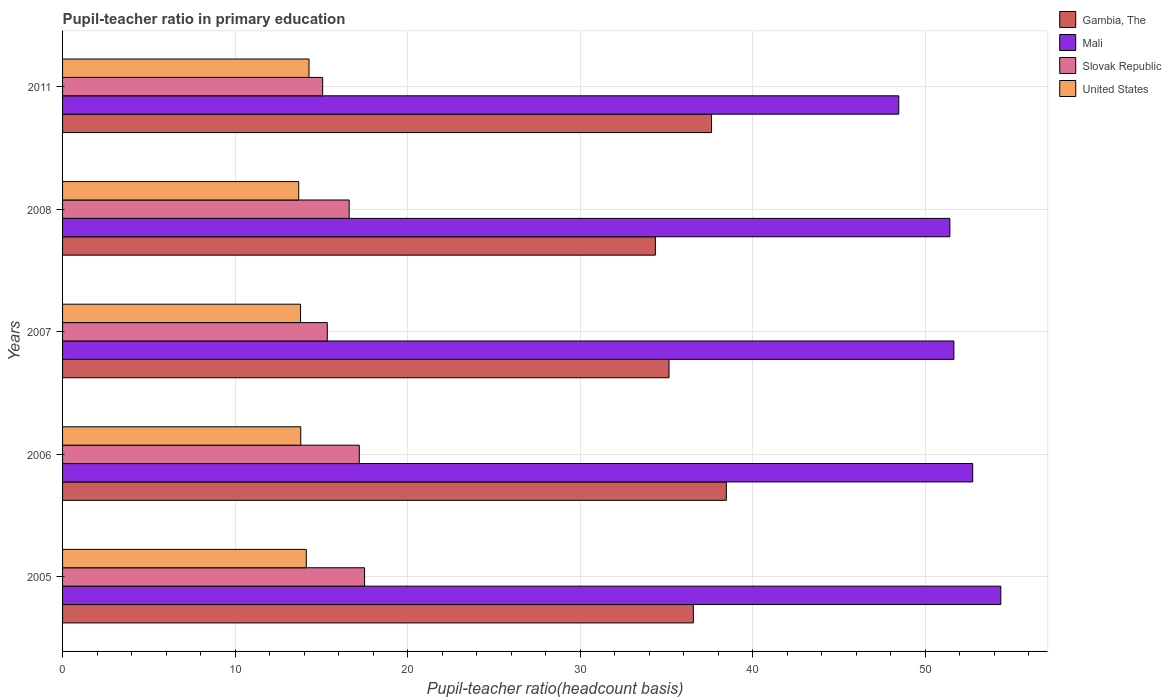Are the number of bars per tick equal to the number of legend labels?
Make the answer very short. Yes. In how many cases, is the number of bars for a given year not equal to the number of legend labels?
Keep it short and to the point. 0. What is the pupil-teacher ratio in primary education in Mali in 2006?
Keep it short and to the point. 52.76. Across all years, what is the maximum pupil-teacher ratio in primary education in Mali?
Your answer should be very brief. 54.39. Across all years, what is the minimum pupil-teacher ratio in primary education in United States?
Provide a succinct answer. 13.69. In which year was the pupil-teacher ratio in primary education in United States maximum?
Your answer should be compact. 2011. In which year was the pupil-teacher ratio in primary education in Slovak Republic minimum?
Give a very brief answer. 2011. What is the total pupil-teacher ratio in primary education in Slovak Republic in the graph?
Give a very brief answer. 81.75. What is the difference between the pupil-teacher ratio in primary education in Mali in 2005 and that in 2007?
Offer a very short reply. 2.72. What is the difference between the pupil-teacher ratio in primary education in Mali in 2006 and the pupil-teacher ratio in primary education in United States in 2007?
Keep it short and to the point. 38.96. What is the average pupil-teacher ratio in primary education in Slovak Republic per year?
Provide a short and direct response. 16.35. In the year 2005, what is the difference between the pupil-teacher ratio in primary education in Slovak Republic and pupil-teacher ratio in primary education in United States?
Give a very brief answer. 3.38. What is the ratio of the pupil-teacher ratio in primary education in Mali in 2007 to that in 2008?
Ensure brevity in your answer.  1. Is the pupil-teacher ratio in primary education in Slovak Republic in 2005 less than that in 2008?
Keep it short and to the point. No. Is the difference between the pupil-teacher ratio in primary education in Slovak Republic in 2006 and 2008 greater than the difference between the pupil-teacher ratio in primary education in United States in 2006 and 2008?
Make the answer very short. Yes. What is the difference between the highest and the second highest pupil-teacher ratio in primary education in Mali?
Your answer should be very brief. 1.63. What is the difference between the highest and the lowest pupil-teacher ratio in primary education in Slovak Republic?
Make the answer very short. 2.43. In how many years, is the pupil-teacher ratio in primary education in Slovak Republic greater than the average pupil-teacher ratio in primary education in Slovak Republic taken over all years?
Ensure brevity in your answer.  3. Is the sum of the pupil-teacher ratio in primary education in Gambia, The in 2005 and 2011 greater than the maximum pupil-teacher ratio in primary education in Mali across all years?
Your answer should be compact. Yes. What does the 2nd bar from the top in 2007 represents?
Your answer should be very brief. Slovak Republic. What does the 2nd bar from the bottom in 2007 represents?
Give a very brief answer. Mali. How many bars are there?
Your answer should be compact. 20. Does the graph contain grids?
Offer a terse response. Yes. How many legend labels are there?
Give a very brief answer. 4. How are the legend labels stacked?
Your answer should be very brief. Vertical. What is the title of the graph?
Your response must be concise. Pupil-teacher ratio in primary education. Does "France" appear as one of the legend labels in the graph?
Your response must be concise. No. What is the label or title of the X-axis?
Your response must be concise. Pupil-teacher ratio(headcount basis). What is the label or title of the Y-axis?
Offer a very short reply. Years. What is the Pupil-teacher ratio(headcount basis) of Gambia, The in 2005?
Provide a succinct answer. 36.56. What is the Pupil-teacher ratio(headcount basis) of Mali in 2005?
Make the answer very short. 54.39. What is the Pupil-teacher ratio(headcount basis) in Slovak Republic in 2005?
Make the answer very short. 17.51. What is the Pupil-teacher ratio(headcount basis) in United States in 2005?
Your answer should be very brief. 14.13. What is the Pupil-teacher ratio(headcount basis) of Gambia, The in 2006?
Provide a succinct answer. 38.48. What is the Pupil-teacher ratio(headcount basis) of Mali in 2006?
Your response must be concise. 52.76. What is the Pupil-teacher ratio(headcount basis) in Slovak Republic in 2006?
Your answer should be compact. 17.2. What is the Pupil-teacher ratio(headcount basis) of United States in 2006?
Your response must be concise. 13.81. What is the Pupil-teacher ratio(headcount basis) of Gambia, The in 2007?
Your response must be concise. 35.16. What is the Pupil-teacher ratio(headcount basis) in Mali in 2007?
Your answer should be very brief. 51.67. What is the Pupil-teacher ratio(headcount basis) of Slovak Republic in 2007?
Make the answer very short. 15.35. What is the Pupil-teacher ratio(headcount basis) of United States in 2007?
Give a very brief answer. 13.8. What is the Pupil-teacher ratio(headcount basis) of Gambia, The in 2008?
Ensure brevity in your answer.  34.36. What is the Pupil-teacher ratio(headcount basis) in Mali in 2008?
Provide a succinct answer. 51.44. What is the Pupil-teacher ratio(headcount basis) in Slovak Republic in 2008?
Provide a succinct answer. 16.61. What is the Pupil-teacher ratio(headcount basis) in United States in 2008?
Make the answer very short. 13.69. What is the Pupil-teacher ratio(headcount basis) of Gambia, The in 2011?
Your answer should be compact. 37.62. What is the Pupil-teacher ratio(headcount basis) of Mali in 2011?
Provide a short and direct response. 48.47. What is the Pupil-teacher ratio(headcount basis) in Slovak Republic in 2011?
Your answer should be compact. 15.08. What is the Pupil-teacher ratio(headcount basis) in United States in 2011?
Offer a terse response. 14.29. Across all years, what is the maximum Pupil-teacher ratio(headcount basis) in Gambia, The?
Provide a short and direct response. 38.48. Across all years, what is the maximum Pupil-teacher ratio(headcount basis) of Mali?
Your answer should be very brief. 54.39. Across all years, what is the maximum Pupil-teacher ratio(headcount basis) in Slovak Republic?
Your answer should be very brief. 17.51. Across all years, what is the maximum Pupil-teacher ratio(headcount basis) in United States?
Provide a short and direct response. 14.29. Across all years, what is the minimum Pupil-teacher ratio(headcount basis) in Gambia, The?
Make the answer very short. 34.36. Across all years, what is the minimum Pupil-teacher ratio(headcount basis) in Mali?
Provide a short and direct response. 48.47. Across all years, what is the minimum Pupil-teacher ratio(headcount basis) in Slovak Republic?
Make the answer very short. 15.08. Across all years, what is the minimum Pupil-teacher ratio(headcount basis) of United States?
Your answer should be very brief. 13.69. What is the total Pupil-teacher ratio(headcount basis) in Gambia, The in the graph?
Your response must be concise. 182.18. What is the total Pupil-teacher ratio(headcount basis) in Mali in the graph?
Make the answer very short. 258.73. What is the total Pupil-teacher ratio(headcount basis) of Slovak Republic in the graph?
Offer a terse response. 81.75. What is the total Pupil-teacher ratio(headcount basis) in United States in the graph?
Provide a short and direct response. 69.71. What is the difference between the Pupil-teacher ratio(headcount basis) of Gambia, The in 2005 and that in 2006?
Your response must be concise. -1.91. What is the difference between the Pupil-teacher ratio(headcount basis) in Mali in 2005 and that in 2006?
Your answer should be very brief. 1.63. What is the difference between the Pupil-teacher ratio(headcount basis) in Slovak Republic in 2005 and that in 2006?
Keep it short and to the point. 0.31. What is the difference between the Pupil-teacher ratio(headcount basis) of United States in 2005 and that in 2006?
Make the answer very short. 0.32. What is the difference between the Pupil-teacher ratio(headcount basis) in Gambia, The in 2005 and that in 2007?
Offer a very short reply. 1.41. What is the difference between the Pupil-teacher ratio(headcount basis) of Mali in 2005 and that in 2007?
Offer a terse response. 2.72. What is the difference between the Pupil-teacher ratio(headcount basis) of Slovak Republic in 2005 and that in 2007?
Your answer should be compact. 2.16. What is the difference between the Pupil-teacher ratio(headcount basis) in United States in 2005 and that in 2007?
Your answer should be very brief. 0.33. What is the difference between the Pupil-teacher ratio(headcount basis) of Gambia, The in 2005 and that in 2008?
Make the answer very short. 2.2. What is the difference between the Pupil-teacher ratio(headcount basis) of Mali in 2005 and that in 2008?
Your response must be concise. 2.95. What is the difference between the Pupil-teacher ratio(headcount basis) of Slovak Republic in 2005 and that in 2008?
Provide a succinct answer. 0.89. What is the difference between the Pupil-teacher ratio(headcount basis) of United States in 2005 and that in 2008?
Provide a short and direct response. 0.44. What is the difference between the Pupil-teacher ratio(headcount basis) of Gambia, The in 2005 and that in 2011?
Your answer should be very brief. -1.05. What is the difference between the Pupil-teacher ratio(headcount basis) of Mali in 2005 and that in 2011?
Ensure brevity in your answer.  5.91. What is the difference between the Pupil-teacher ratio(headcount basis) in Slovak Republic in 2005 and that in 2011?
Give a very brief answer. 2.43. What is the difference between the Pupil-teacher ratio(headcount basis) of United States in 2005 and that in 2011?
Your response must be concise. -0.16. What is the difference between the Pupil-teacher ratio(headcount basis) of Gambia, The in 2006 and that in 2007?
Offer a terse response. 3.32. What is the difference between the Pupil-teacher ratio(headcount basis) in Mali in 2006 and that in 2007?
Make the answer very short. 1.09. What is the difference between the Pupil-teacher ratio(headcount basis) of Slovak Republic in 2006 and that in 2007?
Ensure brevity in your answer.  1.85. What is the difference between the Pupil-teacher ratio(headcount basis) in United States in 2006 and that in 2007?
Provide a succinct answer. 0.01. What is the difference between the Pupil-teacher ratio(headcount basis) in Gambia, The in 2006 and that in 2008?
Make the answer very short. 4.11. What is the difference between the Pupil-teacher ratio(headcount basis) of Mali in 2006 and that in 2008?
Give a very brief answer. 1.32. What is the difference between the Pupil-teacher ratio(headcount basis) in Slovak Republic in 2006 and that in 2008?
Give a very brief answer. 0.59. What is the difference between the Pupil-teacher ratio(headcount basis) in United States in 2006 and that in 2008?
Provide a succinct answer. 0.12. What is the difference between the Pupil-teacher ratio(headcount basis) of Gambia, The in 2006 and that in 2011?
Your answer should be compact. 0.86. What is the difference between the Pupil-teacher ratio(headcount basis) in Mali in 2006 and that in 2011?
Provide a short and direct response. 4.29. What is the difference between the Pupil-teacher ratio(headcount basis) of Slovak Republic in 2006 and that in 2011?
Provide a succinct answer. 2.12. What is the difference between the Pupil-teacher ratio(headcount basis) of United States in 2006 and that in 2011?
Your answer should be very brief. -0.48. What is the difference between the Pupil-teacher ratio(headcount basis) of Gambia, The in 2007 and that in 2008?
Make the answer very short. 0.79. What is the difference between the Pupil-teacher ratio(headcount basis) in Mali in 2007 and that in 2008?
Your answer should be compact. 0.23. What is the difference between the Pupil-teacher ratio(headcount basis) in Slovak Republic in 2007 and that in 2008?
Provide a short and direct response. -1.27. What is the difference between the Pupil-teacher ratio(headcount basis) of United States in 2007 and that in 2008?
Give a very brief answer. 0.11. What is the difference between the Pupil-teacher ratio(headcount basis) of Gambia, The in 2007 and that in 2011?
Provide a succinct answer. -2.46. What is the difference between the Pupil-teacher ratio(headcount basis) of Mali in 2007 and that in 2011?
Provide a succinct answer. 3.2. What is the difference between the Pupil-teacher ratio(headcount basis) of Slovak Republic in 2007 and that in 2011?
Offer a very short reply. 0.27. What is the difference between the Pupil-teacher ratio(headcount basis) in United States in 2007 and that in 2011?
Offer a very short reply. -0.49. What is the difference between the Pupil-teacher ratio(headcount basis) in Gambia, The in 2008 and that in 2011?
Keep it short and to the point. -3.25. What is the difference between the Pupil-teacher ratio(headcount basis) of Mali in 2008 and that in 2011?
Your response must be concise. 2.96. What is the difference between the Pupil-teacher ratio(headcount basis) in Slovak Republic in 2008 and that in 2011?
Offer a terse response. 1.54. What is the difference between the Pupil-teacher ratio(headcount basis) of United States in 2008 and that in 2011?
Your answer should be very brief. -0.6. What is the difference between the Pupil-teacher ratio(headcount basis) in Gambia, The in 2005 and the Pupil-teacher ratio(headcount basis) in Mali in 2006?
Ensure brevity in your answer.  -16.2. What is the difference between the Pupil-teacher ratio(headcount basis) in Gambia, The in 2005 and the Pupil-teacher ratio(headcount basis) in Slovak Republic in 2006?
Offer a very short reply. 19.36. What is the difference between the Pupil-teacher ratio(headcount basis) in Gambia, The in 2005 and the Pupil-teacher ratio(headcount basis) in United States in 2006?
Give a very brief answer. 22.76. What is the difference between the Pupil-teacher ratio(headcount basis) of Mali in 2005 and the Pupil-teacher ratio(headcount basis) of Slovak Republic in 2006?
Keep it short and to the point. 37.19. What is the difference between the Pupil-teacher ratio(headcount basis) in Mali in 2005 and the Pupil-teacher ratio(headcount basis) in United States in 2006?
Keep it short and to the point. 40.58. What is the difference between the Pupil-teacher ratio(headcount basis) in Slovak Republic in 2005 and the Pupil-teacher ratio(headcount basis) in United States in 2006?
Keep it short and to the point. 3.7. What is the difference between the Pupil-teacher ratio(headcount basis) of Gambia, The in 2005 and the Pupil-teacher ratio(headcount basis) of Mali in 2007?
Make the answer very short. -15.1. What is the difference between the Pupil-teacher ratio(headcount basis) in Gambia, The in 2005 and the Pupil-teacher ratio(headcount basis) in Slovak Republic in 2007?
Your answer should be compact. 21.22. What is the difference between the Pupil-teacher ratio(headcount basis) in Gambia, The in 2005 and the Pupil-teacher ratio(headcount basis) in United States in 2007?
Make the answer very short. 22.77. What is the difference between the Pupil-teacher ratio(headcount basis) of Mali in 2005 and the Pupil-teacher ratio(headcount basis) of Slovak Republic in 2007?
Ensure brevity in your answer.  39.04. What is the difference between the Pupil-teacher ratio(headcount basis) of Mali in 2005 and the Pupil-teacher ratio(headcount basis) of United States in 2007?
Your answer should be very brief. 40.59. What is the difference between the Pupil-teacher ratio(headcount basis) in Slovak Republic in 2005 and the Pupil-teacher ratio(headcount basis) in United States in 2007?
Your answer should be compact. 3.71. What is the difference between the Pupil-teacher ratio(headcount basis) in Gambia, The in 2005 and the Pupil-teacher ratio(headcount basis) in Mali in 2008?
Provide a succinct answer. -14.87. What is the difference between the Pupil-teacher ratio(headcount basis) of Gambia, The in 2005 and the Pupil-teacher ratio(headcount basis) of Slovak Republic in 2008?
Your answer should be very brief. 19.95. What is the difference between the Pupil-teacher ratio(headcount basis) in Gambia, The in 2005 and the Pupil-teacher ratio(headcount basis) in United States in 2008?
Provide a succinct answer. 22.88. What is the difference between the Pupil-teacher ratio(headcount basis) in Mali in 2005 and the Pupil-teacher ratio(headcount basis) in Slovak Republic in 2008?
Keep it short and to the point. 37.77. What is the difference between the Pupil-teacher ratio(headcount basis) in Mali in 2005 and the Pupil-teacher ratio(headcount basis) in United States in 2008?
Your answer should be very brief. 40.7. What is the difference between the Pupil-teacher ratio(headcount basis) in Slovak Republic in 2005 and the Pupil-teacher ratio(headcount basis) in United States in 2008?
Give a very brief answer. 3.82. What is the difference between the Pupil-teacher ratio(headcount basis) in Gambia, The in 2005 and the Pupil-teacher ratio(headcount basis) in Mali in 2011?
Make the answer very short. -11.91. What is the difference between the Pupil-teacher ratio(headcount basis) of Gambia, The in 2005 and the Pupil-teacher ratio(headcount basis) of Slovak Republic in 2011?
Make the answer very short. 21.49. What is the difference between the Pupil-teacher ratio(headcount basis) in Gambia, The in 2005 and the Pupil-teacher ratio(headcount basis) in United States in 2011?
Give a very brief answer. 22.28. What is the difference between the Pupil-teacher ratio(headcount basis) in Mali in 2005 and the Pupil-teacher ratio(headcount basis) in Slovak Republic in 2011?
Offer a terse response. 39.31. What is the difference between the Pupil-teacher ratio(headcount basis) in Mali in 2005 and the Pupil-teacher ratio(headcount basis) in United States in 2011?
Offer a terse response. 40.1. What is the difference between the Pupil-teacher ratio(headcount basis) of Slovak Republic in 2005 and the Pupil-teacher ratio(headcount basis) of United States in 2011?
Offer a terse response. 3.22. What is the difference between the Pupil-teacher ratio(headcount basis) of Gambia, The in 2006 and the Pupil-teacher ratio(headcount basis) of Mali in 2007?
Your answer should be very brief. -13.19. What is the difference between the Pupil-teacher ratio(headcount basis) in Gambia, The in 2006 and the Pupil-teacher ratio(headcount basis) in Slovak Republic in 2007?
Provide a succinct answer. 23.13. What is the difference between the Pupil-teacher ratio(headcount basis) in Gambia, The in 2006 and the Pupil-teacher ratio(headcount basis) in United States in 2007?
Give a very brief answer. 24.68. What is the difference between the Pupil-teacher ratio(headcount basis) in Mali in 2006 and the Pupil-teacher ratio(headcount basis) in Slovak Republic in 2007?
Ensure brevity in your answer.  37.41. What is the difference between the Pupil-teacher ratio(headcount basis) in Mali in 2006 and the Pupil-teacher ratio(headcount basis) in United States in 2007?
Give a very brief answer. 38.96. What is the difference between the Pupil-teacher ratio(headcount basis) in Slovak Republic in 2006 and the Pupil-teacher ratio(headcount basis) in United States in 2007?
Ensure brevity in your answer.  3.41. What is the difference between the Pupil-teacher ratio(headcount basis) of Gambia, The in 2006 and the Pupil-teacher ratio(headcount basis) of Mali in 2008?
Keep it short and to the point. -12.96. What is the difference between the Pupil-teacher ratio(headcount basis) in Gambia, The in 2006 and the Pupil-teacher ratio(headcount basis) in Slovak Republic in 2008?
Provide a succinct answer. 21.86. What is the difference between the Pupil-teacher ratio(headcount basis) of Gambia, The in 2006 and the Pupil-teacher ratio(headcount basis) of United States in 2008?
Your answer should be very brief. 24.79. What is the difference between the Pupil-teacher ratio(headcount basis) in Mali in 2006 and the Pupil-teacher ratio(headcount basis) in Slovak Republic in 2008?
Offer a terse response. 36.15. What is the difference between the Pupil-teacher ratio(headcount basis) of Mali in 2006 and the Pupil-teacher ratio(headcount basis) of United States in 2008?
Offer a terse response. 39.07. What is the difference between the Pupil-teacher ratio(headcount basis) of Slovak Republic in 2006 and the Pupil-teacher ratio(headcount basis) of United States in 2008?
Offer a very short reply. 3.51. What is the difference between the Pupil-teacher ratio(headcount basis) in Gambia, The in 2006 and the Pupil-teacher ratio(headcount basis) in Mali in 2011?
Keep it short and to the point. -10. What is the difference between the Pupil-teacher ratio(headcount basis) of Gambia, The in 2006 and the Pupil-teacher ratio(headcount basis) of Slovak Republic in 2011?
Give a very brief answer. 23.4. What is the difference between the Pupil-teacher ratio(headcount basis) of Gambia, The in 2006 and the Pupil-teacher ratio(headcount basis) of United States in 2011?
Provide a short and direct response. 24.19. What is the difference between the Pupil-teacher ratio(headcount basis) of Mali in 2006 and the Pupil-teacher ratio(headcount basis) of Slovak Republic in 2011?
Your response must be concise. 37.68. What is the difference between the Pupil-teacher ratio(headcount basis) of Mali in 2006 and the Pupil-teacher ratio(headcount basis) of United States in 2011?
Your response must be concise. 38.48. What is the difference between the Pupil-teacher ratio(headcount basis) in Slovak Republic in 2006 and the Pupil-teacher ratio(headcount basis) in United States in 2011?
Provide a short and direct response. 2.92. What is the difference between the Pupil-teacher ratio(headcount basis) of Gambia, The in 2007 and the Pupil-teacher ratio(headcount basis) of Mali in 2008?
Your response must be concise. -16.28. What is the difference between the Pupil-teacher ratio(headcount basis) in Gambia, The in 2007 and the Pupil-teacher ratio(headcount basis) in Slovak Republic in 2008?
Provide a short and direct response. 18.54. What is the difference between the Pupil-teacher ratio(headcount basis) in Gambia, The in 2007 and the Pupil-teacher ratio(headcount basis) in United States in 2008?
Offer a terse response. 21.47. What is the difference between the Pupil-teacher ratio(headcount basis) of Mali in 2007 and the Pupil-teacher ratio(headcount basis) of Slovak Republic in 2008?
Provide a short and direct response. 35.05. What is the difference between the Pupil-teacher ratio(headcount basis) in Mali in 2007 and the Pupil-teacher ratio(headcount basis) in United States in 2008?
Give a very brief answer. 37.98. What is the difference between the Pupil-teacher ratio(headcount basis) of Slovak Republic in 2007 and the Pupil-teacher ratio(headcount basis) of United States in 2008?
Your response must be concise. 1.66. What is the difference between the Pupil-teacher ratio(headcount basis) of Gambia, The in 2007 and the Pupil-teacher ratio(headcount basis) of Mali in 2011?
Your answer should be very brief. -13.32. What is the difference between the Pupil-teacher ratio(headcount basis) in Gambia, The in 2007 and the Pupil-teacher ratio(headcount basis) in Slovak Republic in 2011?
Provide a succinct answer. 20.08. What is the difference between the Pupil-teacher ratio(headcount basis) of Gambia, The in 2007 and the Pupil-teacher ratio(headcount basis) of United States in 2011?
Keep it short and to the point. 20.87. What is the difference between the Pupil-teacher ratio(headcount basis) in Mali in 2007 and the Pupil-teacher ratio(headcount basis) in Slovak Republic in 2011?
Provide a short and direct response. 36.59. What is the difference between the Pupil-teacher ratio(headcount basis) in Mali in 2007 and the Pupil-teacher ratio(headcount basis) in United States in 2011?
Provide a short and direct response. 37.38. What is the difference between the Pupil-teacher ratio(headcount basis) of Slovak Republic in 2007 and the Pupil-teacher ratio(headcount basis) of United States in 2011?
Make the answer very short. 1.06. What is the difference between the Pupil-teacher ratio(headcount basis) in Gambia, The in 2008 and the Pupil-teacher ratio(headcount basis) in Mali in 2011?
Your answer should be compact. -14.11. What is the difference between the Pupil-teacher ratio(headcount basis) of Gambia, The in 2008 and the Pupil-teacher ratio(headcount basis) of Slovak Republic in 2011?
Your response must be concise. 19.29. What is the difference between the Pupil-teacher ratio(headcount basis) of Gambia, The in 2008 and the Pupil-teacher ratio(headcount basis) of United States in 2011?
Make the answer very short. 20.08. What is the difference between the Pupil-teacher ratio(headcount basis) in Mali in 2008 and the Pupil-teacher ratio(headcount basis) in Slovak Republic in 2011?
Offer a very short reply. 36.36. What is the difference between the Pupil-teacher ratio(headcount basis) in Mali in 2008 and the Pupil-teacher ratio(headcount basis) in United States in 2011?
Offer a terse response. 37.15. What is the difference between the Pupil-teacher ratio(headcount basis) in Slovak Republic in 2008 and the Pupil-teacher ratio(headcount basis) in United States in 2011?
Keep it short and to the point. 2.33. What is the average Pupil-teacher ratio(headcount basis) in Gambia, The per year?
Provide a short and direct response. 36.44. What is the average Pupil-teacher ratio(headcount basis) in Mali per year?
Keep it short and to the point. 51.75. What is the average Pupil-teacher ratio(headcount basis) of Slovak Republic per year?
Your response must be concise. 16.35. What is the average Pupil-teacher ratio(headcount basis) of United States per year?
Give a very brief answer. 13.94. In the year 2005, what is the difference between the Pupil-teacher ratio(headcount basis) in Gambia, The and Pupil-teacher ratio(headcount basis) in Mali?
Offer a terse response. -17.82. In the year 2005, what is the difference between the Pupil-teacher ratio(headcount basis) of Gambia, The and Pupil-teacher ratio(headcount basis) of Slovak Republic?
Make the answer very short. 19.06. In the year 2005, what is the difference between the Pupil-teacher ratio(headcount basis) in Gambia, The and Pupil-teacher ratio(headcount basis) in United States?
Offer a very short reply. 22.43. In the year 2005, what is the difference between the Pupil-teacher ratio(headcount basis) of Mali and Pupil-teacher ratio(headcount basis) of Slovak Republic?
Your answer should be very brief. 36.88. In the year 2005, what is the difference between the Pupil-teacher ratio(headcount basis) in Mali and Pupil-teacher ratio(headcount basis) in United States?
Offer a very short reply. 40.26. In the year 2005, what is the difference between the Pupil-teacher ratio(headcount basis) of Slovak Republic and Pupil-teacher ratio(headcount basis) of United States?
Your answer should be compact. 3.38. In the year 2006, what is the difference between the Pupil-teacher ratio(headcount basis) in Gambia, The and Pupil-teacher ratio(headcount basis) in Mali?
Provide a short and direct response. -14.28. In the year 2006, what is the difference between the Pupil-teacher ratio(headcount basis) in Gambia, The and Pupil-teacher ratio(headcount basis) in Slovak Republic?
Provide a short and direct response. 21.28. In the year 2006, what is the difference between the Pupil-teacher ratio(headcount basis) of Gambia, The and Pupil-teacher ratio(headcount basis) of United States?
Keep it short and to the point. 24.67. In the year 2006, what is the difference between the Pupil-teacher ratio(headcount basis) of Mali and Pupil-teacher ratio(headcount basis) of Slovak Republic?
Offer a very short reply. 35.56. In the year 2006, what is the difference between the Pupil-teacher ratio(headcount basis) in Mali and Pupil-teacher ratio(headcount basis) in United States?
Make the answer very short. 38.95. In the year 2006, what is the difference between the Pupil-teacher ratio(headcount basis) in Slovak Republic and Pupil-teacher ratio(headcount basis) in United States?
Your answer should be very brief. 3.39. In the year 2007, what is the difference between the Pupil-teacher ratio(headcount basis) in Gambia, The and Pupil-teacher ratio(headcount basis) in Mali?
Make the answer very short. -16.51. In the year 2007, what is the difference between the Pupil-teacher ratio(headcount basis) in Gambia, The and Pupil-teacher ratio(headcount basis) in Slovak Republic?
Your response must be concise. 19.81. In the year 2007, what is the difference between the Pupil-teacher ratio(headcount basis) of Gambia, The and Pupil-teacher ratio(headcount basis) of United States?
Keep it short and to the point. 21.36. In the year 2007, what is the difference between the Pupil-teacher ratio(headcount basis) in Mali and Pupil-teacher ratio(headcount basis) in Slovak Republic?
Provide a succinct answer. 36.32. In the year 2007, what is the difference between the Pupil-teacher ratio(headcount basis) of Mali and Pupil-teacher ratio(headcount basis) of United States?
Ensure brevity in your answer.  37.87. In the year 2007, what is the difference between the Pupil-teacher ratio(headcount basis) in Slovak Republic and Pupil-teacher ratio(headcount basis) in United States?
Offer a very short reply. 1.55. In the year 2008, what is the difference between the Pupil-teacher ratio(headcount basis) of Gambia, The and Pupil-teacher ratio(headcount basis) of Mali?
Your answer should be compact. -17.07. In the year 2008, what is the difference between the Pupil-teacher ratio(headcount basis) in Gambia, The and Pupil-teacher ratio(headcount basis) in Slovak Republic?
Your answer should be compact. 17.75. In the year 2008, what is the difference between the Pupil-teacher ratio(headcount basis) of Gambia, The and Pupil-teacher ratio(headcount basis) of United States?
Provide a short and direct response. 20.68. In the year 2008, what is the difference between the Pupil-teacher ratio(headcount basis) in Mali and Pupil-teacher ratio(headcount basis) in Slovak Republic?
Your answer should be very brief. 34.82. In the year 2008, what is the difference between the Pupil-teacher ratio(headcount basis) in Mali and Pupil-teacher ratio(headcount basis) in United States?
Your answer should be very brief. 37.75. In the year 2008, what is the difference between the Pupil-teacher ratio(headcount basis) in Slovak Republic and Pupil-teacher ratio(headcount basis) in United States?
Provide a succinct answer. 2.92. In the year 2011, what is the difference between the Pupil-teacher ratio(headcount basis) in Gambia, The and Pupil-teacher ratio(headcount basis) in Mali?
Keep it short and to the point. -10.85. In the year 2011, what is the difference between the Pupil-teacher ratio(headcount basis) in Gambia, The and Pupil-teacher ratio(headcount basis) in Slovak Republic?
Your answer should be very brief. 22.54. In the year 2011, what is the difference between the Pupil-teacher ratio(headcount basis) in Gambia, The and Pupil-teacher ratio(headcount basis) in United States?
Offer a very short reply. 23.33. In the year 2011, what is the difference between the Pupil-teacher ratio(headcount basis) of Mali and Pupil-teacher ratio(headcount basis) of Slovak Republic?
Offer a very short reply. 33.39. In the year 2011, what is the difference between the Pupil-teacher ratio(headcount basis) of Mali and Pupil-teacher ratio(headcount basis) of United States?
Your answer should be very brief. 34.19. In the year 2011, what is the difference between the Pupil-teacher ratio(headcount basis) in Slovak Republic and Pupil-teacher ratio(headcount basis) in United States?
Offer a terse response. 0.79. What is the ratio of the Pupil-teacher ratio(headcount basis) in Gambia, The in 2005 to that in 2006?
Provide a short and direct response. 0.95. What is the ratio of the Pupil-teacher ratio(headcount basis) of Mali in 2005 to that in 2006?
Keep it short and to the point. 1.03. What is the ratio of the Pupil-teacher ratio(headcount basis) of Slovak Republic in 2005 to that in 2006?
Offer a terse response. 1.02. What is the ratio of the Pupil-teacher ratio(headcount basis) of United States in 2005 to that in 2006?
Ensure brevity in your answer.  1.02. What is the ratio of the Pupil-teacher ratio(headcount basis) of Gambia, The in 2005 to that in 2007?
Give a very brief answer. 1.04. What is the ratio of the Pupil-teacher ratio(headcount basis) in Mali in 2005 to that in 2007?
Ensure brevity in your answer.  1.05. What is the ratio of the Pupil-teacher ratio(headcount basis) in Slovak Republic in 2005 to that in 2007?
Keep it short and to the point. 1.14. What is the ratio of the Pupil-teacher ratio(headcount basis) of United States in 2005 to that in 2007?
Keep it short and to the point. 1.02. What is the ratio of the Pupil-teacher ratio(headcount basis) of Gambia, The in 2005 to that in 2008?
Provide a succinct answer. 1.06. What is the ratio of the Pupil-teacher ratio(headcount basis) of Mali in 2005 to that in 2008?
Make the answer very short. 1.06. What is the ratio of the Pupil-teacher ratio(headcount basis) of Slovak Republic in 2005 to that in 2008?
Keep it short and to the point. 1.05. What is the ratio of the Pupil-teacher ratio(headcount basis) in United States in 2005 to that in 2008?
Your answer should be compact. 1.03. What is the ratio of the Pupil-teacher ratio(headcount basis) of Mali in 2005 to that in 2011?
Provide a succinct answer. 1.12. What is the ratio of the Pupil-teacher ratio(headcount basis) in Slovak Republic in 2005 to that in 2011?
Keep it short and to the point. 1.16. What is the ratio of the Pupil-teacher ratio(headcount basis) in Gambia, The in 2006 to that in 2007?
Provide a short and direct response. 1.09. What is the ratio of the Pupil-teacher ratio(headcount basis) in Mali in 2006 to that in 2007?
Offer a very short reply. 1.02. What is the ratio of the Pupil-teacher ratio(headcount basis) of Slovak Republic in 2006 to that in 2007?
Your response must be concise. 1.12. What is the ratio of the Pupil-teacher ratio(headcount basis) of United States in 2006 to that in 2007?
Provide a short and direct response. 1. What is the ratio of the Pupil-teacher ratio(headcount basis) of Gambia, The in 2006 to that in 2008?
Keep it short and to the point. 1.12. What is the ratio of the Pupil-teacher ratio(headcount basis) of Mali in 2006 to that in 2008?
Provide a short and direct response. 1.03. What is the ratio of the Pupil-teacher ratio(headcount basis) in Slovak Republic in 2006 to that in 2008?
Ensure brevity in your answer.  1.04. What is the ratio of the Pupil-teacher ratio(headcount basis) of United States in 2006 to that in 2008?
Ensure brevity in your answer.  1.01. What is the ratio of the Pupil-teacher ratio(headcount basis) in Gambia, The in 2006 to that in 2011?
Keep it short and to the point. 1.02. What is the ratio of the Pupil-teacher ratio(headcount basis) of Mali in 2006 to that in 2011?
Your response must be concise. 1.09. What is the ratio of the Pupil-teacher ratio(headcount basis) of Slovak Republic in 2006 to that in 2011?
Offer a terse response. 1.14. What is the ratio of the Pupil-teacher ratio(headcount basis) of United States in 2006 to that in 2011?
Your answer should be very brief. 0.97. What is the ratio of the Pupil-teacher ratio(headcount basis) in Gambia, The in 2007 to that in 2008?
Offer a very short reply. 1.02. What is the ratio of the Pupil-teacher ratio(headcount basis) in Mali in 2007 to that in 2008?
Offer a very short reply. 1. What is the ratio of the Pupil-teacher ratio(headcount basis) of Slovak Republic in 2007 to that in 2008?
Offer a terse response. 0.92. What is the ratio of the Pupil-teacher ratio(headcount basis) in United States in 2007 to that in 2008?
Provide a short and direct response. 1.01. What is the ratio of the Pupil-teacher ratio(headcount basis) of Gambia, The in 2007 to that in 2011?
Make the answer very short. 0.93. What is the ratio of the Pupil-teacher ratio(headcount basis) of Mali in 2007 to that in 2011?
Make the answer very short. 1.07. What is the ratio of the Pupil-teacher ratio(headcount basis) in Slovak Republic in 2007 to that in 2011?
Offer a very short reply. 1.02. What is the ratio of the Pupil-teacher ratio(headcount basis) in United States in 2007 to that in 2011?
Ensure brevity in your answer.  0.97. What is the ratio of the Pupil-teacher ratio(headcount basis) of Gambia, The in 2008 to that in 2011?
Your answer should be very brief. 0.91. What is the ratio of the Pupil-teacher ratio(headcount basis) of Mali in 2008 to that in 2011?
Your answer should be very brief. 1.06. What is the ratio of the Pupil-teacher ratio(headcount basis) of Slovak Republic in 2008 to that in 2011?
Provide a succinct answer. 1.1. What is the ratio of the Pupil-teacher ratio(headcount basis) of United States in 2008 to that in 2011?
Your answer should be compact. 0.96. What is the difference between the highest and the second highest Pupil-teacher ratio(headcount basis) in Gambia, The?
Provide a short and direct response. 0.86. What is the difference between the highest and the second highest Pupil-teacher ratio(headcount basis) in Mali?
Provide a succinct answer. 1.63. What is the difference between the highest and the second highest Pupil-teacher ratio(headcount basis) in Slovak Republic?
Provide a short and direct response. 0.31. What is the difference between the highest and the second highest Pupil-teacher ratio(headcount basis) of United States?
Your answer should be very brief. 0.16. What is the difference between the highest and the lowest Pupil-teacher ratio(headcount basis) in Gambia, The?
Keep it short and to the point. 4.11. What is the difference between the highest and the lowest Pupil-teacher ratio(headcount basis) in Mali?
Your answer should be compact. 5.91. What is the difference between the highest and the lowest Pupil-teacher ratio(headcount basis) of Slovak Republic?
Your response must be concise. 2.43. What is the difference between the highest and the lowest Pupil-teacher ratio(headcount basis) of United States?
Give a very brief answer. 0.6. 